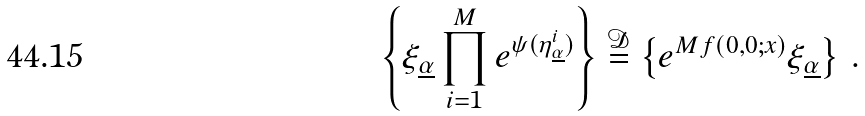<formula> <loc_0><loc_0><loc_500><loc_500>\left \{ \xi _ { \underline { \alpha } } \prod _ { i = 1 } ^ { M } e ^ { \psi ( \eta ^ { i } _ { \underline { \alpha } } ) } \right \} \stackrel { \mathcal { D } } { = } \left \{ e ^ { M f ( 0 , 0 ; x ) } \xi _ { \underline { \alpha } } \right \} \, .</formula> 